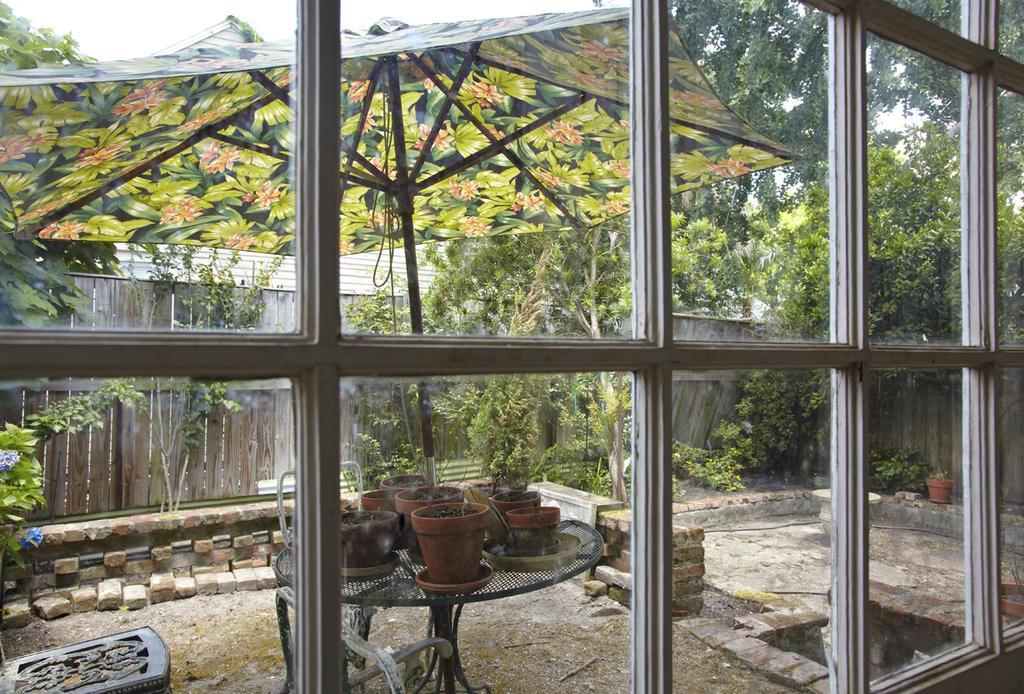How would you summarize this image in a sentence or two? In this picture, it seems like windows in the foreground area of the image, there are plant pots on a table, an umbrella, bricks, wooden wall, trees and the sky in the background. 